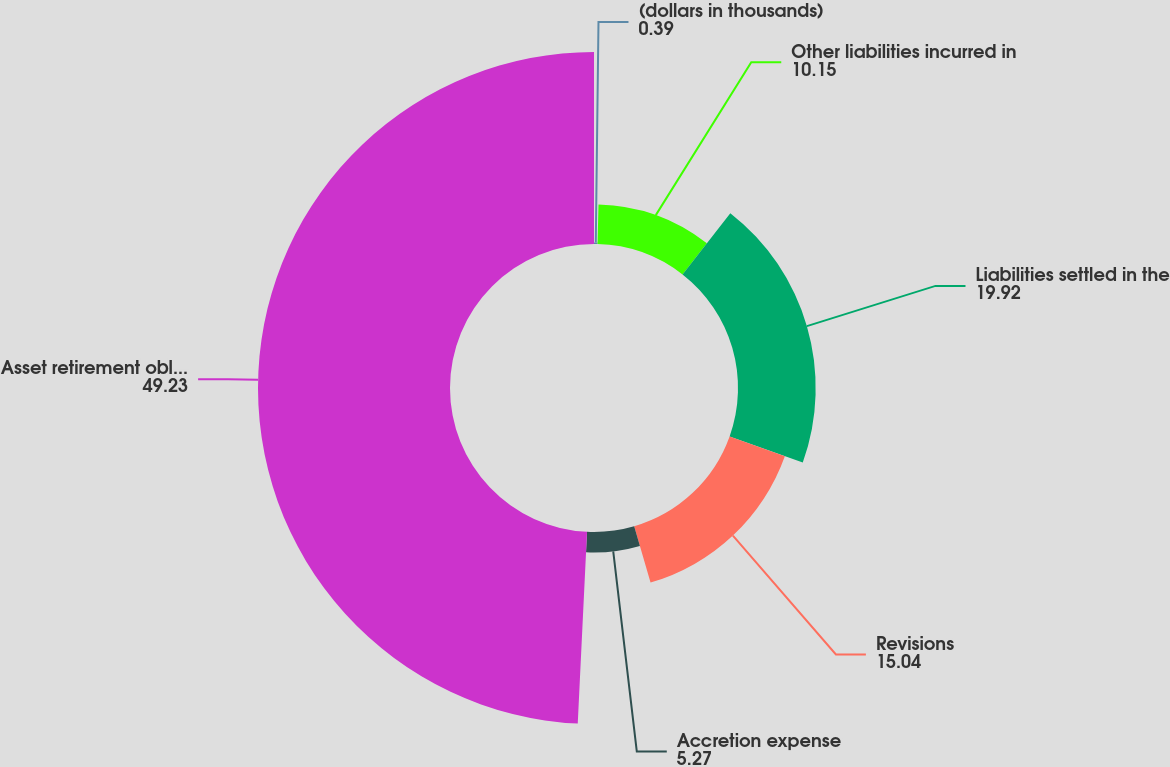Convert chart to OTSL. <chart><loc_0><loc_0><loc_500><loc_500><pie_chart><fcel>(dollars in thousands)<fcel>Other liabilities incurred in<fcel>Liabilities settled in the<fcel>Revisions<fcel>Accretion expense<fcel>Asset retirement obligation at<nl><fcel>0.39%<fcel>10.15%<fcel>19.92%<fcel>15.04%<fcel>5.27%<fcel>49.23%<nl></chart> 